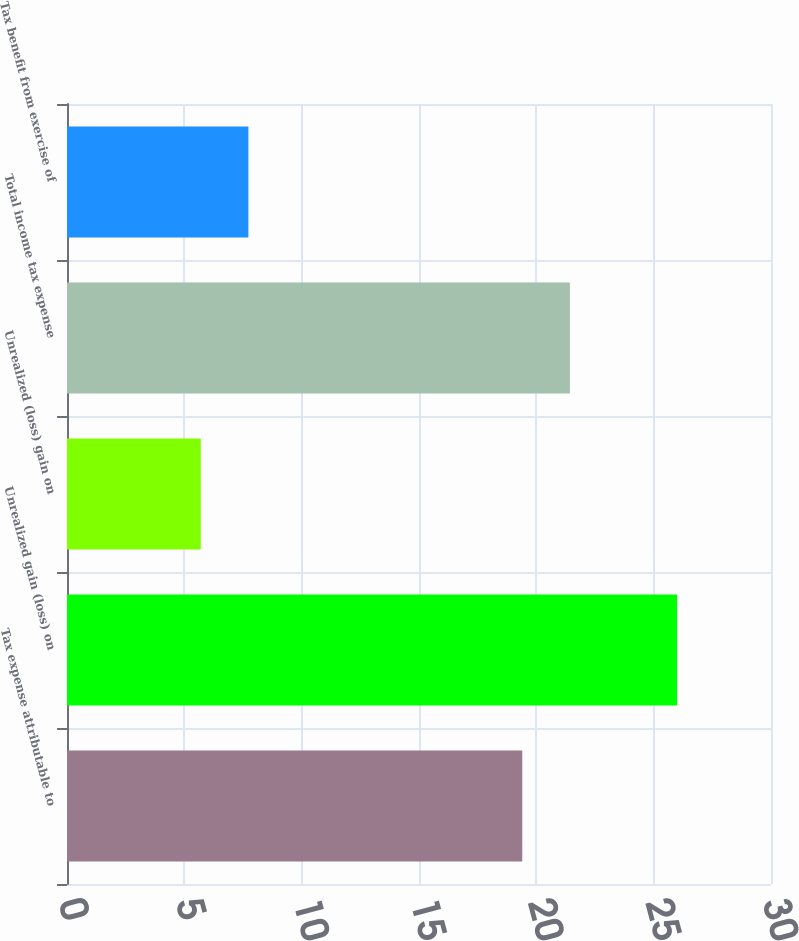<chart> <loc_0><loc_0><loc_500><loc_500><bar_chart><fcel>Tax expense attributable to<fcel>Unrealized gain (loss) on<fcel>Unrealized (loss) gain on<fcel>Total income tax expense<fcel>Tax benefit from exercise of<nl><fcel>19.4<fcel>26<fcel>5.7<fcel>21.43<fcel>7.73<nl></chart> 